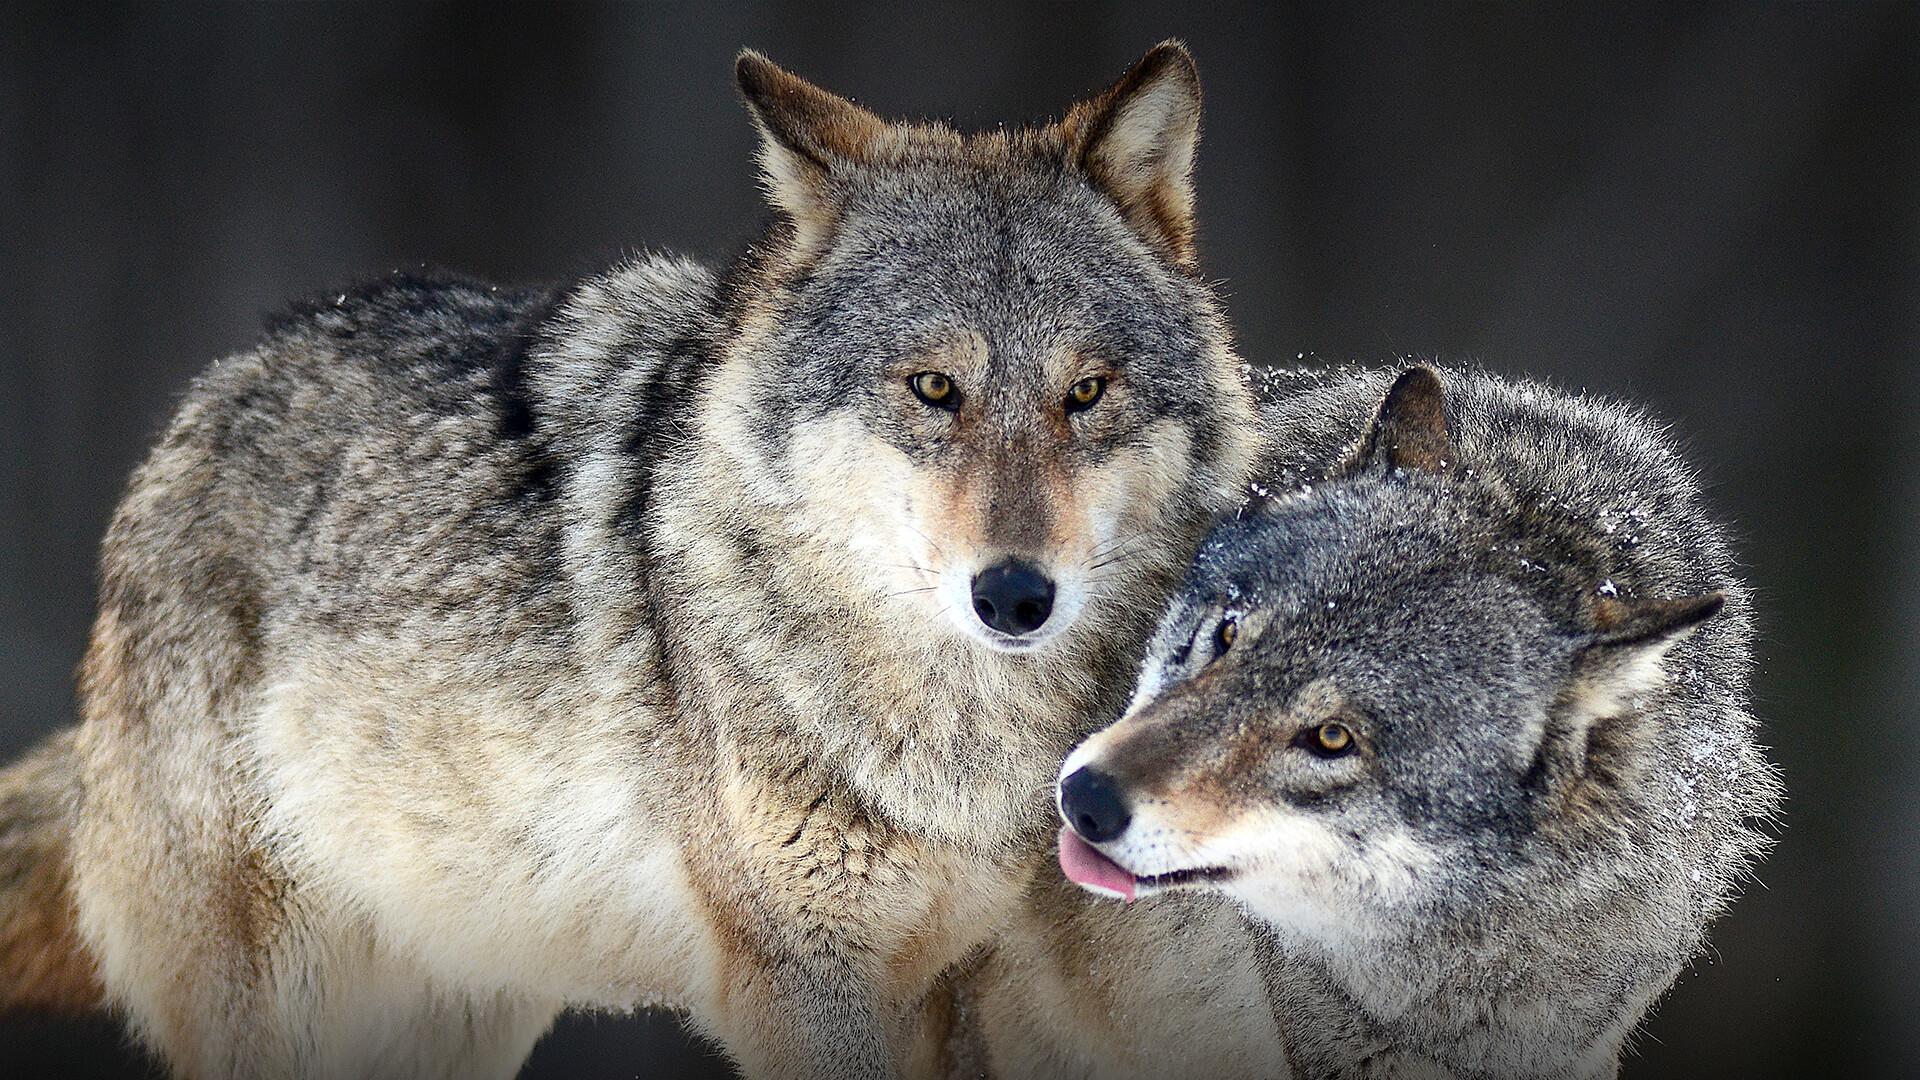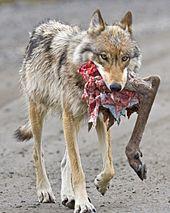The first image is the image on the left, the second image is the image on the right. Analyze the images presented: Is the assertion "One image shows two wolves with their faces side-by-side, and the other image features one forward-looking wolf." valid? Answer yes or no. Yes. The first image is the image on the left, the second image is the image on the right. For the images shown, is this caption "there are two wolves standing close together" true? Answer yes or no. Yes. 